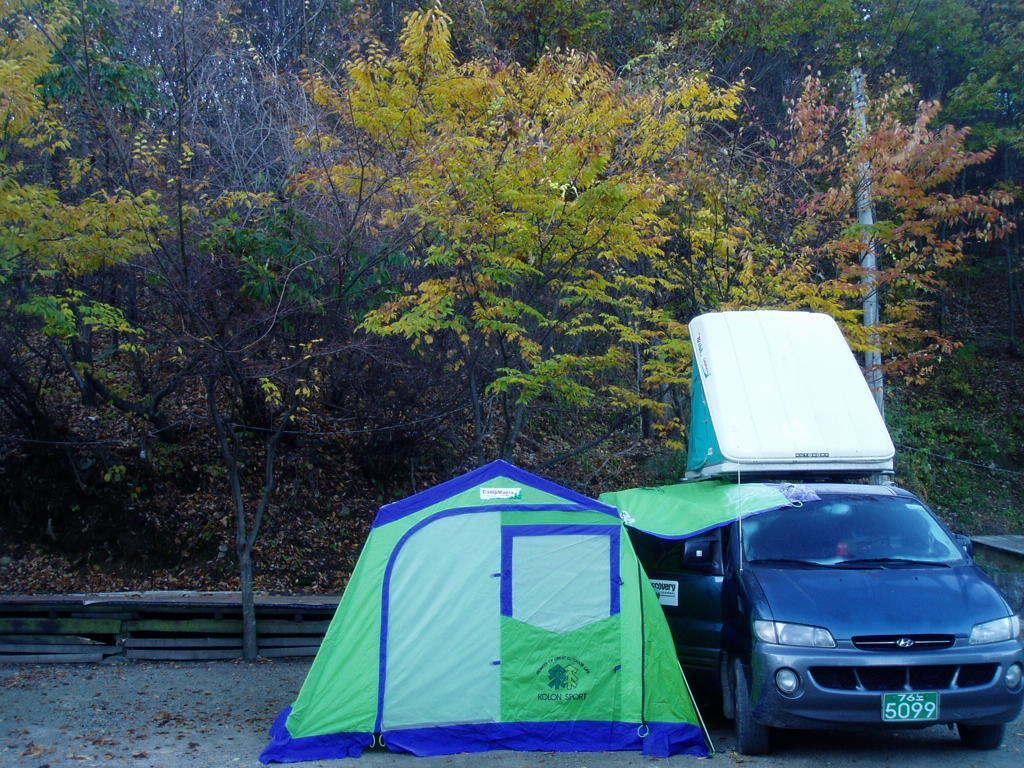Could you give a brief overview of what you see in this image? In this image, we can see a vehicle and a tent on the road and in the background, there are trees and we can see a pole and a fence. 